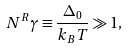<formula> <loc_0><loc_0><loc_500><loc_500>N ^ { R } \gamma \equiv \frac { \Delta _ { 0 } } { k _ { B } T } \gg 1 ,</formula> 